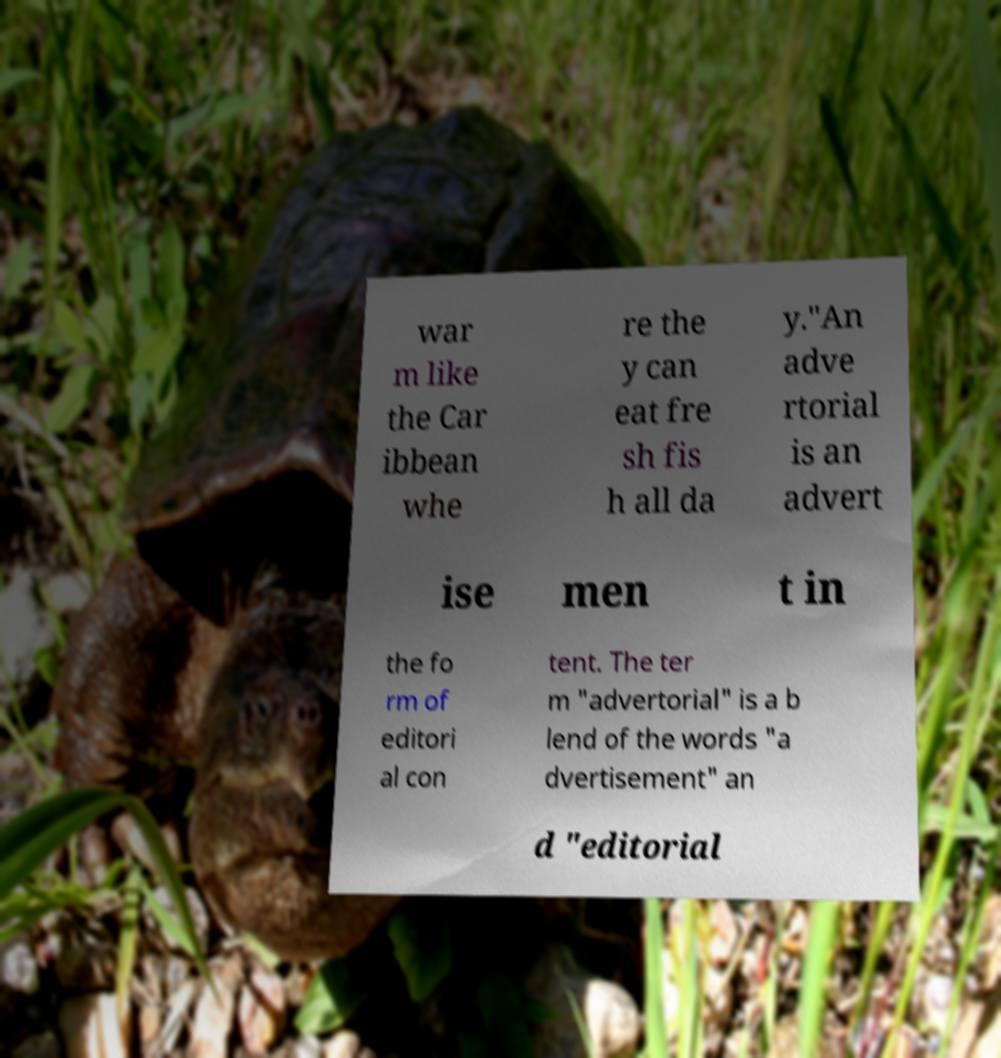Could you extract and type out the text from this image? war m like the Car ibbean whe re the y can eat fre sh fis h all da y."An adve rtorial is an advert ise men t in the fo rm of editori al con tent. The ter m "advertorial" is a b lend of the words "a dvertisement" an d "editorial 